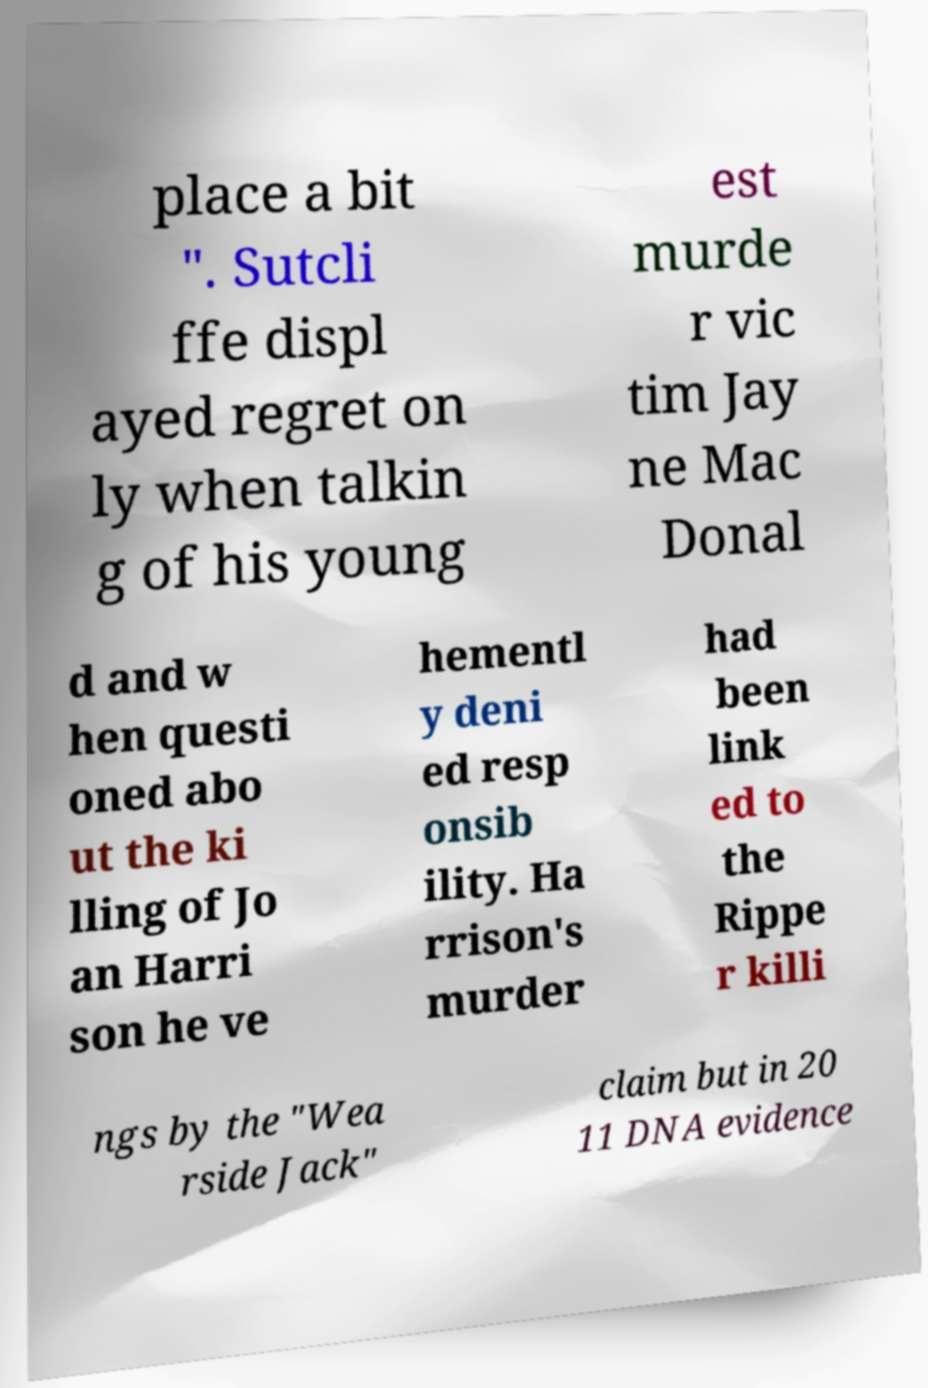Could you assist in decoding the text presented in this image and type it out clearly? place a bit ". Sutcli ffe displ ayed regret on ly when talkin g of his young est murde r vic tim Jay ne Mac Donal d and w hen questi oned abo ut the ki lling of Jo an Harri son he ve hementl y deni ed resp onsib ility. Ha rrison's murder had been link ed to the Rippe r killi ngs by the "Wea rside Jack" claim but in 20 11 DNA evidence 